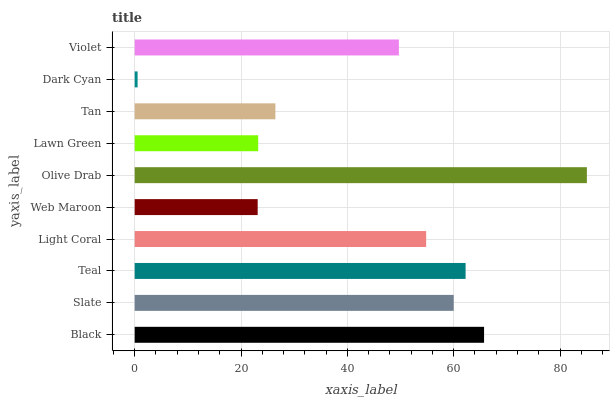Is Dark Cyan the minimum?
Answer yes or no. Yes. Is Olive Drab the maximum?
Answer yes or no. Yes. Is Slate the minimum?
Answer yes or no. No. Is Slate the maximum?
Answer yes or no. No. Is Black greater than Slate?
Answer yes or no. Yes. Is Slate less than Black?
Answer yes or no. Yes. Is Slate greater than Black?
Answer yes or no. No. Is Black less than Slate?
Answer yes or no. No. Is Light Coral the high median?
Answer yes or no. Yes. Is Violet the low median?
Answer yes or no. Yes. Is Lawn Green the high median?
Answer yes or no. No. Is Teal the low median?
Answer yes or no. No. 